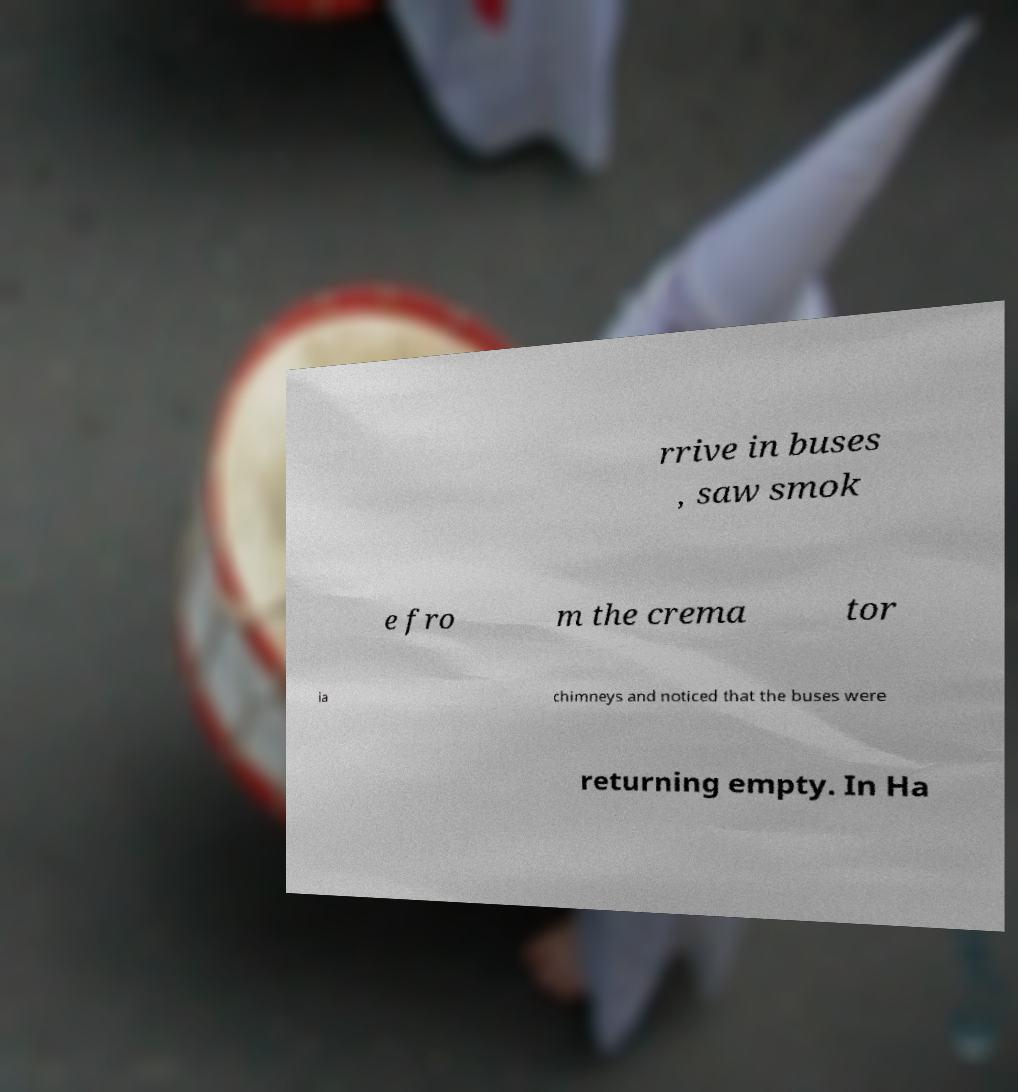Could you assist in decoding the text presented in this image and type it out clearly? rrive in buses , saw smok e fro m the crema tor ia chimneys and noticed that the buses were returning empty. In Ha 